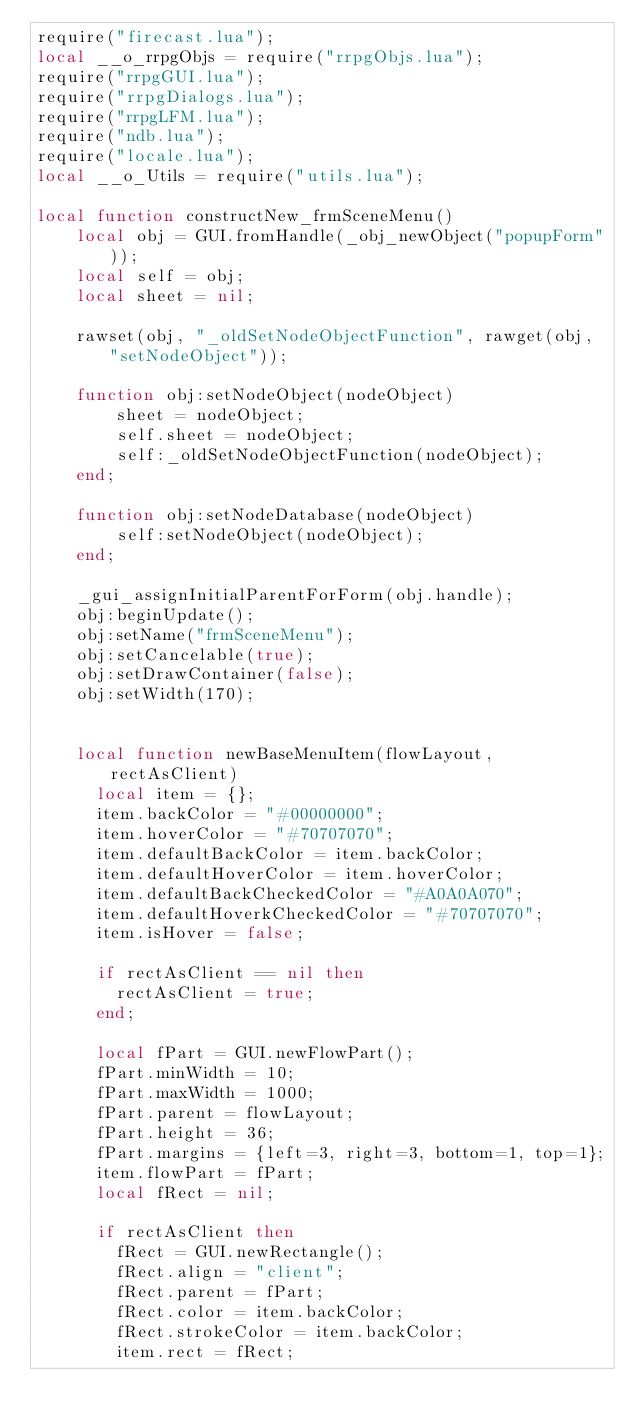<code> <loc_0><loc_0><loc_500><loc_500><_Lua_>require("firecast.lua");
local __o_rrpgObjs = require("rrpgObjs.lua");
require("rrpgGUI.lua");
require("rrpgDialogs.lua");
require("rrpgLFM.lua");
require("ndb.lua");
require("locale.lua");
local __o_Utils = require("utils.lua");

local function constructNew_frmSceneMenu()
    local obj = GUI.fromHandle(_obj_newObject("popupForm"));
    local self = obj;
    local sheet = nil;

    rawset(obj, "_oldSetNodeObjectFunction", rawget(obj, "setNodeObject"));

    function obj:setNodeObject(nodeObject)
        sheet = nodeObject;
        self.sheet = nodeObject;
        self:_oldSetNodeObjectFunction(nodeObject);
    end;

    function obj:setNodeDatabase(nodeObject)
        self:setNodeObject(nodeObject);
    end;

    _gui_assignInitialParentForForm(obj.handle);
    obj:beginUpdate();
    obj:setName("frmSceneMenu");
    obj:setCancelable(true);
    obj:setDrawContainer(false);
    obj:setWidth(170);

		
		local function newBaseMenuItem(flowLayout, rectAsClient)
			local item = {};
			item.backColor = "#00000000";
			item.hoverColor = "#70707070";				
			item.defaultBackColor = item.backColor;
			item.defaultHoverColor = item.hoverColor;
			item.defaultBackCheckedColor = "#A0A0A070";
			item.defaultHoverkCheckedColor = "#70707070";
			item.isHover = false;
		
			if rectAsClient == nil then
				rectAsClient = true;
			end;
		
			local fPart = GUI.newFlowPart();
			fPart.minWidth = 10;
			fPart.maxWidth = 1000;
			fPart.parent = flowLayout;
			fPart.height = 36;
			fPart.margins = {left=3, right=3, bottom=1, top=1};
			item.flowPart = fPart;
			local fRect = nil;
			
			if rectAsClient then
				fRect = GUI.newRectangle();
				fRect.align = "client";
				fRect.parent = fPart;
				fRect.color = item.backColor;
				fRect.strokeColor = item.backColor;
				item.rect = fRect;</code> 